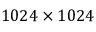Convert formula to latex. <formula><loc_0><loc_0><loc_500><loc_500>1 0 2 4 \times 1 0 2 4</formula> 